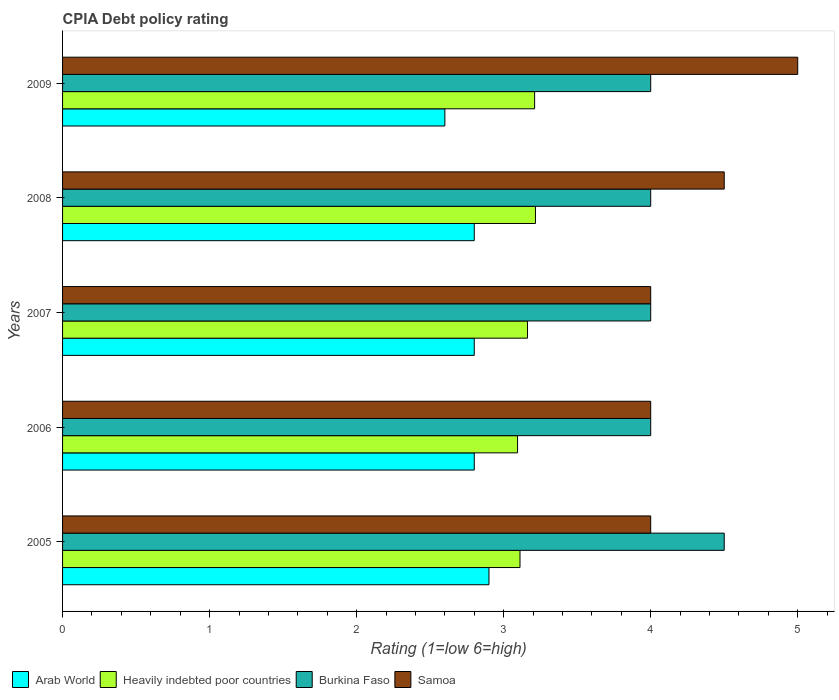How many different coloured bars are there?
Keep it short and to the point. 4. How many groups of bars are there?
Your response must be concise. 5. How many bars are there on the 2nd tick from the top?
Offer a very short reply. 4. What is the CPIA rating in Heavily indebted poor countries in 2005?
Your answer should be compact. 3.11. Across all years, what is the maximum CPIA rating in Heavily indebted poor countries?
Provide a short and direct response. 3.22. What is the total CPIA rating in Heavily indebted poor countries in the graph?
Make the answer very short. 15.79. What is the difference between the CPIA rating in Samoa in 2006 and the CPIA rating in Heavily indebted poor countries in 2009?
Make the answer very short. 0.79. What is the average CPIA rating in Arab World per year?
Make the answer very short. 2.78. In the year 2008, what is the difference between the CPIA rating in Heavily indebted poor countries and CPIA rating in Samoa?
Ensure brevity in your answer.  -1.28. In how many years, is the CPIA rating in Samoa greater than 2.4 ?
Your answer should be compact. 5. What is the ratio of the CPIA rating in Burkina Faso in 2005 to that in 2009?
Keep it short and to the point. 1.12. What is the difference between the highest and the second highest CPIA rating in Arab World?
Ensure brevity in your answer.  0.1. What is the difference between the highest and the lowest CPIA rating in Arab World?
Ensure brevity in your answer.  0.3. Is the sum of the CPIA rating in Heavily indebted poor countries in 2005 and 2006 greater than the maximum CPIA rating in Burkina Faso across all years?
Your answer should be very brief. Yes. Is it the case that in every year, the sum of the CPIA rating in Burkina Faso and CPIA rating in Samoa is greater than the sum of CPIA rating in Arab World and CPIA rating in Heavily indebted poor countries?
Your response must be concise. No. What does the 3rd bar from the top in 2007 represents?
Provide a succinct answer. Heavily indebted poor countries. What does the 1st bar from the bottom in 2005 represents?
Your answer should be very brief. Arab World. How many bars are there?
Provide a short and direct response. 20. What is the difference between two consecutive major ticks on the X-axis?
Your answer should be very brief. 1. Are the values on the major ticks of X-axis written in scientific E-notation?
Offer a terse response. No. How many legend labels are there?
Provide a short and direct response. 4. How are the legend labels stacked?
Ensure brevity in your answer.  Horizontal. What is the title of the graph?
Provide a short and direct response. CPIA Debt policy rating. What is the label or title of the X-axis?
Offer a very short reply. Rating (1=low 6=high). What is the label or title of the Y-axis?
Your answer should be very brief. Years. What is the Rating (1=low 6=high) in Heavily indebted poor countries in 2005?
Provide a succinct answer. 3.11. What is the Rating (1=low 6=high) in Burkina Faso in 2005?
Make the answer very short. 4.5. What is the Rating (1=low 6=high) in Heavily indebted poor countries in 2006?
Your response must be concise. 3.09. What is the Rating (1=low 6=high) of Burkina Faso in 2006?
Give a very brief answer. 4. What is the Rating (1=low 6=high) of Samoa in 2006?
Provide a short and direct response. 4. What is the Rating (1=low 6=high) in Arab World in 2007?
Make the answer very short. 2.8. What is the Rating (1=low 6=high) of Heavily indebted poor countries in 2007?
Keep it short and to the point. 3.16. What is the Rating (1=low 6=high) in Burkina Faso in 2007?
Give a very brief answer. 4. What is the Rating (1=low 6=high) of Samoa in 2007?
Offer a very short reply. 4. What is the Rating (1=low 6=high) of Arab World in 2008?
Offer a terse response. 2.8. What is the Rating (1=low 6=high) of Heavily indebted poor countries in 2008?
Your response must be concise. 3.22. What is the Rating (1=low 6=high) in Burkina Faso in 2008?
Provide a short and direct response. 4. What is the Rating (1=low 6=high) in Samoa in 2008?
Your response must be concise. 4.5. What is the Rating (1=low 6=high) of Heavily indebted poor countries in 2009?
Your answer should be very brief. 3.21. What is the Rating (1=low 6=high) of Burkina Faso in 2009?
Ensure brevity in your answer.  4. What is the Rating (1=low 6=high) of Samoa in 2009?
Keep it short and to the point. 5. Across all years, what is the maximum Rating (1=low 6=high) of Heavily indebted poor countries?
Offer a very short reply. 3.22. Across all years, what is the maximum Rating (1=low 6=high) of Burkina Faso?
Your response must be concise. 4.5. Across all years, what is the maximum Rating (1=low 6=high) of Samoa?
Your answer should be very brief. 5. Across all years, what is the minimum Rating (1=low 6=high) in Heavily indebted poor countries?
Provide a succinct answer. 3.09. Across all years, what is the minimum Rating (1=low 6=high) of Samoa?
Offer a very short reply. 4. What is the total Rating (1=low 6=high) in Arab World in the graph?
Provide a succinct answer. 13.9. What is the total Rating (1=low 6=high) of Heavily indebted poor countries in the graph?
Ensure brevity in your answer.  15.79. What is the total Rating (1=low 6=high) in Samoa in the graph?
Make the answer very short. 21.5. What is the difference between the Rating (1=low 6=high) in Arab World in 2005 and that in 2006?
Make the answer very short. 0.1. What is the difference between the Rating (1=low 6=high) of Heavily indebted poor countries in 2005 and that in 2006?
Your answer should be very brief. 0.02. What is the difference between the Rating (1=low 6=high) of Burkina Faso in 2005 and that in 2006?
Give a very brief answer. 0.5. What is the difference between the Rating (1=low 6=high) of Samoa in 2005 and that in 2006?
Provide a succinct answer. 0. What is the difference between the Rating (1=low 6=high) in Arab World in 2005 and that in 2007?
Your answer should be very brief. 0.1. What is the difference between the Rating (1=low 6=high) in Heavily indebted poor countries in 2005 and that in 2007?
Your response must be concise. -0.05. What is the difference between the Rating (1=low 6=high) of Burkina Faso in 2005 and that in 2007?
Offer a terse response. 0.5. What is the difference between the Rating (1=low 6=high) in Heavily indebted poor countries in 2005 and that in 2008?
Give a very brief answer. -0.11. What is the difference between the Rating (1=low 6=high) in Burkina Faso in 2005 and that in 2008?
Keep it short and to the point. 0.5. What is the difference between the Rating (1=low 6=high) of Arab World in 2005 and that in 2009?
Your answer should be compact. 0.3. What is the difference between the Rating (1=low 6=high) in Heavily indebted poor countries in 2005 and that in 2009?
Keep it short and to the point. -0.1. What is the difference between the Rating (1=low 6=high) of Arab World in 2006 and that in 2007?
Offer a terse response. 0. What is the difference between the Rating (1=low 6=high) in Heavily indebted poor countries in 2006 and that in 2007?
Provide a short and direct response. -0.07. What is the difference between the Rating (1=low 6=high) of Burkina Faso in 2006 and that in 2007?
Keep it short and to the point. 0. What is the difference between the Rating (1=low 6=high) in Samoa in 2006 and that in 2007?
Make the answer very short. 0. What is the difference between the Rating (1=low 6=high) of Arab World in 2006 and that in 2008?
Ensure brevity in your answer.  0. What is the difference between the Rating (1=low 6=high) in Heavily indebted poor countries in 2006 and that in 2008?
Your response must be concise. -0.12. What is the difference between the Rating (1=low 6=high) in Burkina Faso in 2006 and that in 2008?
Offer a terse response. 0. What is the difference between the Rating (1=low 6=high) of Heavily indebted poor countries in 2006 and that in 2009?
Your answer should be very brief. -0.12. What is the difference between the Rating (1=low 6=high) of Heavily indebted poor countries in 2007 and that in 2008?
Make the answer very short. -0.05. What is the difference between the Rating (1=low 6=high) in Burkina Faso in 2007 and that in 2008?
Provide a short and direct response. 0. What is the difference between the Rating (1=low 6=high) of Arab World in 2007 and that in 2009?
Your answer should be compact. 0.2. What is the difference between the Rating (1=low 6=high) in Heavily indebted poor countries in 2007 and that in 2009?
Your answer should be compact. -0.05. What is the difference between the Rating (1=low 6=high) of Burkina Faso in 2007 and that in 2009?
Make the answer very short. 0. What is the difference between the Rating (1=low 6=high) in Arab World in 2008 and that in 2009?
Make the answer very short. 0.2. What is the difference between the Rating (1=low 6=high) in Heavily indebted poor countries in 2008 and that in 2009?
Your answer should be compact. 0.01. What is the difference between the Rating (1=low 6=high) in Samoa in 2008 and that in 2009?
Your answer should be compact. -0.5. What is the difference between the Rating (1=low 6=high) of Arab World in 2005 and the Rating (1=low 6=high) of Heavily indebted poor countries in 2006?
Offer a very short reply. -0.19. What is the difference between the Rating (1=low 6=high) of Heavily indebted poor countries in 2005 and the Rating (1=low 6=high) of Burkina Faso in 2006?
Your response must be concise. -0.89. What is the difference between the Rating (1=low 6=high) in Heavily indebted poor countries in 2005 and the Rating (1=low 6=high) in Samoa in 2006?
Make the answer very short. -0.89. What is the difference between the Rating (1=low 6=high) in Arab World in 2005 and the Rating (1=low 6=high) in Heavily indebted poor countries in 2007?
Keep it short and to the point. -0.26. What is the difference between the Rating (1=low 6=high) in Arab World in 2005 and the Rating (1=low 6=high) in Burkina Faso in 2007?
Provide a short and direct response. -1.1. What is the difference between the Rating (1=low 6=high) of Heavily indebted poor countries in 2005 and the Rating (1=low 6=high) of Burkina Faso in 2007?
Offer a very short reply. -0.89. What is the difference between the Rating (1=low 6=high) in Heavily indebted poor countries in 2005 and the Rating (1=low 6=high) in Samoa in 2007?
Provide a succinct answer. -0.89. What is the difference between the Rating (1=low 6=high) of Burkina Faso in 2005 and the Rating (1=low 6=high) of Samoa in 2007?
Give a very brief answer. 0.5. What is the difference between the Rating (1=low 6=high) in Arab World in 2005 and the Rating (1=low 6=high) in Heavily indebted poor countries in 2008?
Offer a very short reply. -0.32. What is the difference between the Rating (1=low 6=high) in Arab World in 2005 and the Rating (1=low 6=high) in Samoa in 2008?
Keep it short and to the point. -1.6. What is the difference between the Rating (1=low 6=high) in Heavily indebted poor countries in 2005 and the Rating (1=low 6=high) in Burkina Faso in 2008?
Offer a terse response. -0.89. What is the difference between the Rating (1=low 6=high) in Heavily indebted poor countries in 2005 and the Rating (1=low 6=high) in Samoa in 2008?
Provide a succinct answer. -1.39. What is the difference between the Rating (1=low 6=high) of Burkina Faso in 2005 and the Rating (1=low 6=high) of Samoa in 2008?
Provide a succinct answer. 0. What is the difference between the Rating (1=low 6=high) in Arab World in 2005 and the Rating (1=low 6=high) in Heavily indebted poor countries in 2009?
Keep it short and to the point. -0.31. What is the difference between the Rating (1=low 6=high) in Arab World in 2005 and the Rating (1=low 6=high) in Burkina Faso in 2009?
Give a very brief answer. -1.1. What is the difference between the Rating (1=low 6=high) of Heavily indebted poor countries in 2005 and the Rating (1=low 6=high) of Burkina Faso in 2009?
Offer a terse response. -0.89. What is the difference between the Rating (1=low 6=high) in Heavily indebted poor countries in 2005 and the Rating (1=low 6=high) in Samoa in 2009?
Offer a terse response. -1.89. What is the difference between the Rating (1=low 6=high) in Arab World in 2006 and the Rating (1=low 6=high) in Heavily indebted poor countries in 2007?
Your answer should be very brief. -0.36. What is the difference between the Rating (1=low 6=high) in Arab World in 2006 and the Rating (1=low 6=high) in Burkina Faso in 2007?
Keep it short and to the point. -1.2. What is the difference between the Rating (1=low 6=high) of Arab World in 2006 and the Rating (1=low 6=high) of Samoa in 2007?
Provide a short and direct response. -1.2. What is the difference between the Rating (1=low 6=high) of Heavily indebted poor countries in 2006 and the Rating (1=low 6=high) of Burkina Faso in 2007?
Offer a terse response. -0.91. What is the difference between the Rating (1=low 6=high) in Heavily indebted poor countries in 2006 and the Rating (1=low 6=high) in Samoa in 2007?
Provide a succinct answer. -0.91. What is the difference between the Rating (1=low 6=high) of Burkina Faso in 2006 and the Rating (1=low 6=high) of Samoa in 2007?
Your response must be concise. 0. What is the difference between the Rating (1=low 6=high) of Arab World in 2006 and the Rating (1=low 6=high) of Heavily indebted poor countries in 2008?
Your answer should be very brief. -0.42. What is the difference between the Rating (1=low 6=high) in Arab World in 2006 and the Rating (1=low 6=high) in Burkina Faso in 2008?
Your response must be concise. -1.2. What is the difference between the Rating (1=low 6=high) in Heavily indebted poor countries in 2006 and the Rating (1=low 6=high) in Burkina Faso in 2008?
Ensure brevity in your answer.  -0.91. What is the difference between the Rating (1=low 6=high) of Heavily indebted poor countries in 2006 and the Rating (1=low 6=high) of Samoa in 2008?
Give a very brief answer. -1.41. What is the difference between the Rating (1=low 6=high) of Arab World in 2006 and the Rating (1=low 6=high) of Heavily indebted poor countries in 2009?
Your answer should be compact. -0.41. What is the difference between the Rating (1=low 6=high) of Heavily indebted poor countries in 2006 and the Rating (1=low 6=high) of Burkina Faso in 2009?
Keep it short and to the point. -0.91. What is the difference between the Rating (1=low 6=high) of Heavily indebted poor countries in 2006 and the Rating (1=low 6=high) of Samoa in 2009?
Your response must be concise. -1.91. What is the difference between the Rating (1=low 6=high) in Burkina Faso in 2006 and the Rating (1=low 6=high) in Samoa in 2009?
Keep it short and to the point. -1. What is the difference between the Rating (1=low 6=high) of Arab World in 2007 and the Rating (1=low 6=high) of Heavily indebted poor countries in 2008?
Offer a terse response. -0.42. What is the difference between the Rating (1=low 6=high) of Arab World in 2007 and the Rating (1=low 6=high) of Burkina Faso in 2008?
Keep it short and to the point. -1.2. What is the difference between the Rating (1=low 6=high) in Arab World in 2007 and the Rating (1=low 6=high) in Samoa in 2008?
Your response must be concise. -1.7. What is the difference between the Rating (1=low 6=high) of Heavily indebted poor countries in 2007 and the Rating (1=low 6=high) of Burkina Faso in 2008?
Your answer should be very brief. -0.84. What is the difference between the Rating (1=low 6=high) in Heavily indebted poor countries in 2007 and the Rating (1=low 6=high) in Samoa in 2008?
Offer a very short reply. -1.34. What is the difference between the Rating (1=low 6=high) in Arab World in 2007 and the Rating (1=low 6=high) in Heavily indebted poor countries in 2009?
Your answer should be very brief. -0.41. What is the difference between the Rating (1=low 6=high) in Arab World in 2007 and the Rating (1=low 6=high) in Samoa in 2009?
Your answer should be very brief. -2.2. What is the difference between the Rating (1=low 6=high) in Heavily indebted poor countries in 2007 and the Rating (1=low 6=high) in Burkina Faso in 2009?
Keep it short and to the point. -0.84. What is the difference between the Rating (1=low 6=high) in Heavily indebted poor countries in 2007 and the Rating (1=low 6=high) in Samoa in 2009?
Provide a short and direct response. -1.84. What is the difference between the Rating (1=low 6=high) of Burkina Faso in 2007 and the Rating (1=low 6=high) of Samoa in 2009?
Give a very brief answer. -1. What is the difference between the Rating (1=low 6=high) of Arab World in 2008 and the Rating (1=low 6=high) of Heavily indebted poor countries in 2009?
Provide a short and direct response. -0.41. What is the difference between the Rating (1=low 6=high) of Heavily indebted poor countries in 2008 and the Rating (1=low 6=high) of Burkina Faso in 2009?
Provide a short and direct response. -0.78. What is the difference between the Rating (1=low 6=high) in Heavily indebted poor countries in 2008 and the Rating (1=low 6=high) in Samoa in 2009?
Provide a succinct answer. -1.78. What is the difference between the Rating (1=low 6=high) of Burkina Faso in 2008 and the Rating (1=low 6=high) of Samoa in 2009?
Make the answer very short. -1. What is the average Rating (1=low 6=high) of Arab World per year?
Your response must be concise. 2.78. What is the average Rating (1=low 6=high) of Heavily indebted poor countries per year?
Offer a terse response. 3.16. In the year 2005, what is the difference between the Rating (1=low 6=high) of Arab World and Rating (1=low 6=high) of Heavily indebted poor countries?
Your answer should be very brief. -0.21. In the year 2005, what is the difference between the Rating (1=low 6=high) of Arab World and Rating (1=low 6=high) of Burkina Faso?
Offer a very short reply. -1.6. In the year 2005, what is the difference between the Rating (1=low 6=high) in Heavily indebted poor countries and Rating (1=low 6=high) in Burkina Faso?
Make the answer very short. -1.39. In the year 2005, what is the difference between the Rating (1=low 6=high) of Heavily indebted poor countries and Rating (1=low 6=high) of Samoa?
Provide a succinct answer. -0.89. In the year 2006, what is the difference between the Rating (1=low 6=high) in Arab World and Rating (1=low 6=high) in Heavily indebted poor countries?
Provide a short and direct response. -0.29. In the year 2006, what is the difference between the Rating (1=low 6=high) of Arab World and Rating (1=low 6=high) of Burkina Faso?
Make the answer very short. -1.2. In the year 2006, what is the difference between the Rating (1=low 6=high) in Heavily indebted poor countries and Rating (1=low 6=high) in Burkina Faso?
Your response must be concise. -0.91. In the year 2006, what is the difference between the Rating (1=low 6=high) of Heavily indebted poor countries and Rating (1=low 6=high) of Samoa?
Give a very brief answer. -0.91. In the year 2007, what is the difference between the Rating (1=low 6=high) in Arab World and Rating (1=low 6=high) in Heavily indebted poor countries?
Offer a terse response. -0.36. In the year 2007, what is the difference between the Rating (1=low 6=high) of Arab World and Rating (1=low 6=high) of Burkina Faso?
Your answer should be very brief. -1.2. In the year 2007, what is the difference between the Rating (1=low 6=high) of Heavily indebted poor countries and Rating (1=low 6=high) of Burkina Faso?
Your response must be concise. -0.84. In the year 2007, what is the difference between the Rating (1=low 6=high) of Heavily indebted poor countries and Rating (1=low 6=high) of Samoa?
Make the answer very short. -0.84. In the year 2008, what is the difference between the Rating (1=low 6=high) of Arab World and Rating (1=low 6=high) of Heavily indebted poor countries?
Provide a short and direct response. -0.42. In the year 2008, what is the difference between the Rating (1=low 6=high) of Arab World and Rating (1=low 6=high) of Burkina Faso?
Give a very brief answer. -1.2. In the year 2008, what is the difference between the Rating (1=low 6=high) in Arab World and Rating (1=low 6=high) in Samoa?
Give a very brief answer. -1.7. In the year 2008, what is the difference between the Rating (1=low 6=high) in Heavily indebted poor countries and Rating (1=low 6=high) in Burkina Faso?
Keep it short and to the point. -0.78. In the year 2008, what is the difference between the Rating (1=low 6=high) in Heavily indebted poor countries and Rating (1=low 6=high) in Samoa?
Your response must be concise. -1.28. In the year 2008, what is the difference between the Rating (1=low 6=high) of Burkina Faso and Rating (1=low 6=high) of Samoa?
Offer a terse response. -0.5. In the year 2009, what is the difference between the Rating (1=low 6=high) of Arab World and Rating (1=low 6=high) of Heavily indebted poor countries?
Provide a short and direct response. -0.61. In the year 2009, what is the difference between the Rating (1=low 6=high) in Heavily indebted poor countries and Rating (1=low 6=high) in Burkina Faso?
Offer a terse response. -0.79. In the year 2009, what is the difference between the Rating (1=low 6=high) of Heavily indebted poor countries and Rating (1=low 6=high) of Samoa?
Ensure brevity in your answer.  -1.79. In the year 2009, what is the difference between the Rating (1=low 6=high) of Burkina Faso and Rating (1=low 6=high) of Samoa?
Provide a short and direct response. -1. What is the ratio of the Rating (1=low 6=high) of Arab World in 2005 to that in 2006?
Give a very brief answer. 1.04. What is the ratio of the Rating (1=low 6=high) in Heavily indebted poor countries in 2005 to that in 2006?
Provide a short and direct response. 1.01. What is the ratio of the Rating (1=low 6=high) in Burkina Faso in 2005 to that in 2006?
Offer a terse response. 1.12. What is the ratio of the Rating (1=low 6=high) of Samoa in 2005 to that in 2006?
Ensure brevity in your answer.  1. What is the ratio of the Rating (1=low 6=high) of Arab World in 2005 to that in 2007?
Your response must be concise. 1.04. What is the ratio of the Rating (1=low 6=high) of Heavily indebted poor countries in 2005 to that in 2007?
Provide a short and direct response. 0.98. What is the ratio of the Rating (1=low 6=high) of Burkina Faso in 2005 to that in 2007?
Offer a terse response. 1.12. What is the ratio of the Rating (1=low 6=high) of Samoa in 2005 to that in 2007?
Keep it short and to the point. 1. What is the ratio of the Rating (1=low 6=high) of Arab World in 2005 to that in 2008?
Offer a very short reply. 1.04. What is the ratio of the Rating (1=low 6=high) of Heavily indebted poor countries in 2005 to that in 2008?
Ensure brevity in your answer.  0.97. What is the ratio of the Rating (1=low 6=high) in Burkina Faso in 2005 to that in 2008?
Provide a short and direct response. 1.12. What is the ratio of the Rating (1=low 6=high) in Arab World in 2005 to that in 2009?
Offer a very short reply. 1.12. What is the ratio of the Rating (1=low 6=high) of Samoa in 2005 to that in 2009?
Your answer should be compact. 0.8. What is the ratio of the Rating (1=low 6=high) of Heavily indebted poor countries in 2006 to that in 2007?
Ensure brevity in your answer.  0.98. What is the ratio of the Rating (1=low 6=high) of Arab World in 2006 to that in 2008?
Keep it short and to the point. 1. What is the ratio of the Rating (1=low 6=high) of Heavily indebted poor countries in 2006 to that in 2008?
Ensure brevity in your answer.  0.96. What is the ratio of the Rating (1=low 6=high) of Burkina Faso in 2006 to that in 2008?
Your answer should be compact. 1. What is the ratio of the Rating (1=low 6=high) in Arab World in 2006 to that in 2009?
Your response must be concise. 1.08. What is the ratio of the Rating (1=low 6=high) in Heavily indebted poor countries in 2006 to that in 2009?
Give a very brief answer. 0.96. What is the ratio of the Rating (1=low 6=high) of Samoa in 2006 to that in 2009?
Offer a very short reply. 0.8. What is the ratio of the Rating (1=low 6=high) of Heavily indebted poor countries in 2007 to that in 2008?
Provide a short and direct response. 0.98. What is the ratio of the Rating (1=low 6=high) in Samoa in 2007 to that in 2008?
Offer a terse response. 0.89. What is the ratio of the Rating (1=low 6=high) of Arab World in 2007 to that in 2009?
Offer a very short reply. 1.08. What is the ratio of the Rating (1=low 6=high) of Heavily indebted poor countries in 2007 to that in 2009?
Provide a succinct answer. 0.98. What is the ratio of the Rating (1=low 6=high) of Burkina Faso in 2007 to that in 2009?
Make the answer very short. 1. What is the ratio of the Rating (1=low 6=high) in Samoa in 2007 to that in 2009?
Keep it short and to the point. 0.8. What is the ratio of the Rating (1=low 6=high) of Arab World in 2008 to that in 2009?
Your answer should be compact. 1.08. What is the ratio of the Rating (1=low 6=high) of Heavily indebted poor countries in 2008 to that in 2009?
Your response must be concise. 1. What is the difference between the highest and the second highest Rating (1=low 6=high) of Heavily indebted poor countries?
Your response must be concise. 0.01. What is the difference between the highest and the lowest Rating (1=low 6=high) in Heavily indebted poor countries?
Ensure brevity in your answer.  0.12. 